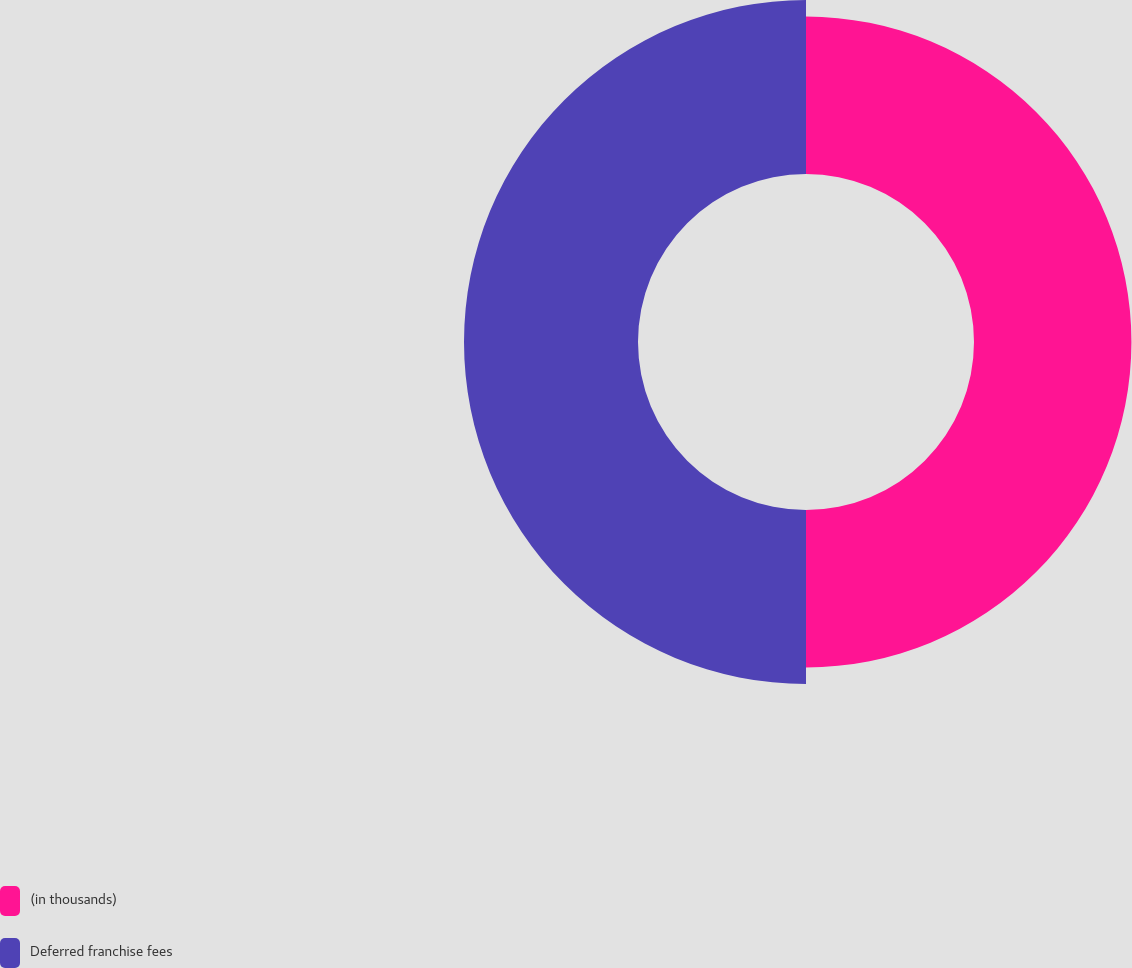Convert chart to OTSL. <chart><loc_0><loc_0><loc_500><loc_500><pie_chart><fcel>(in thousands)<fcel>Deferred franchise fees<nl><fcel>47.5%<fcel>52.5%<nl></chart> 